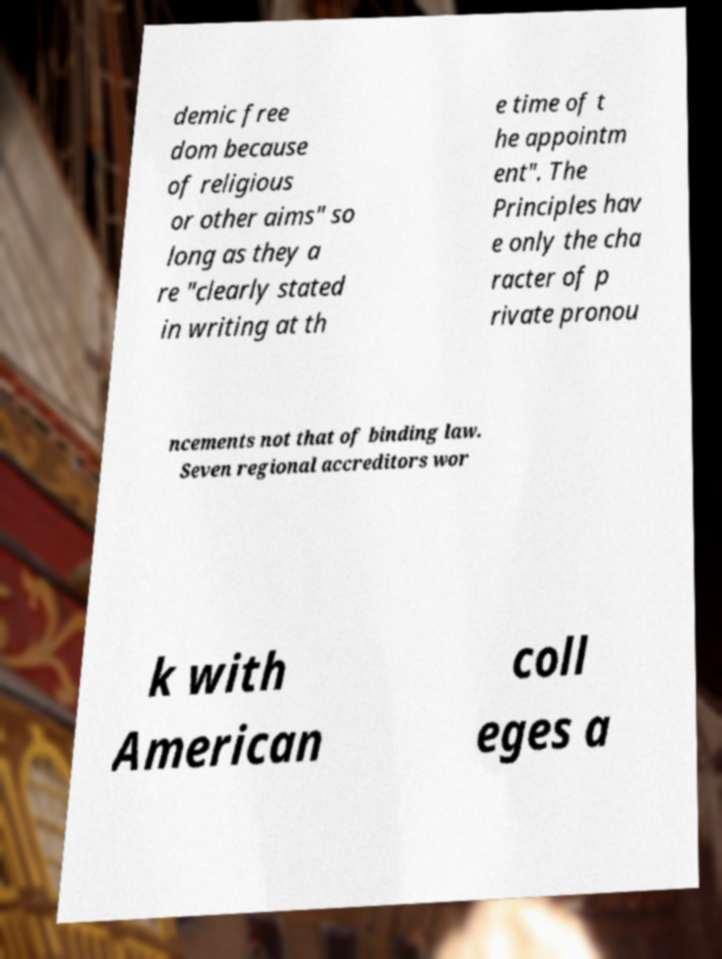Please identify and transcribe the text found in this image. demic free dom because of religious or other aims" so long as they a re "clearly stated in writing at th e time of t he appointm ent". The Principles hav e only the cha racter of p rivate pronou ncements not that of binding law. Seven regional accreditors wor k with American coll eges a 